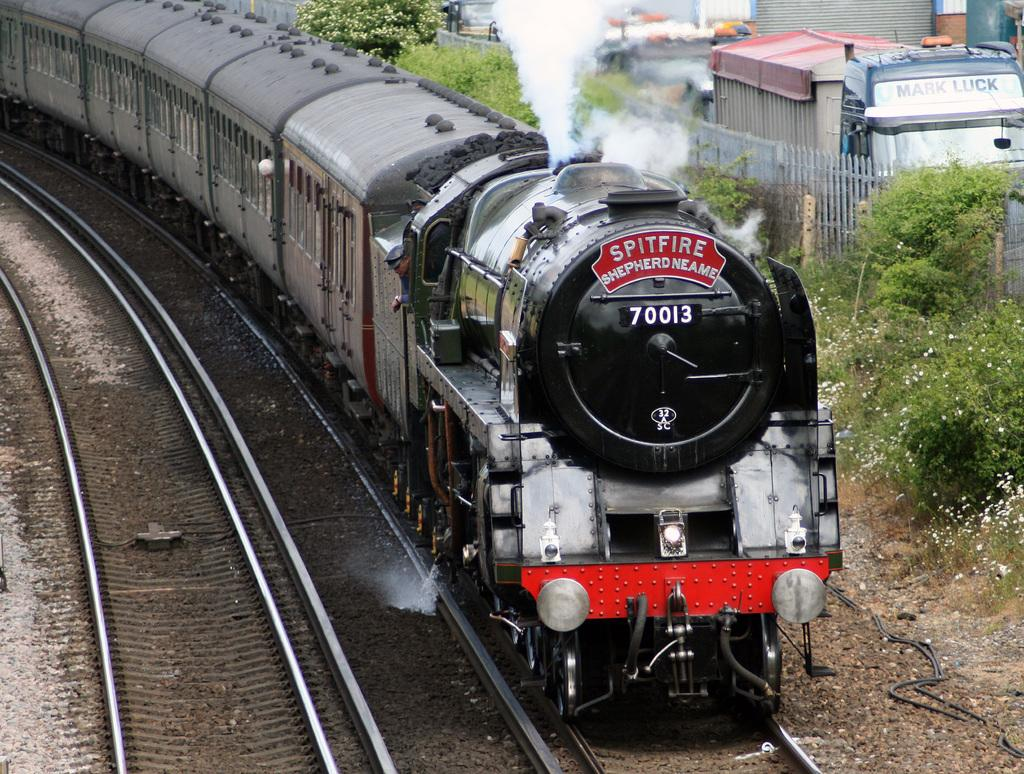<image>
Describe the image concisely. Black train with the number 70013 going down the track. 